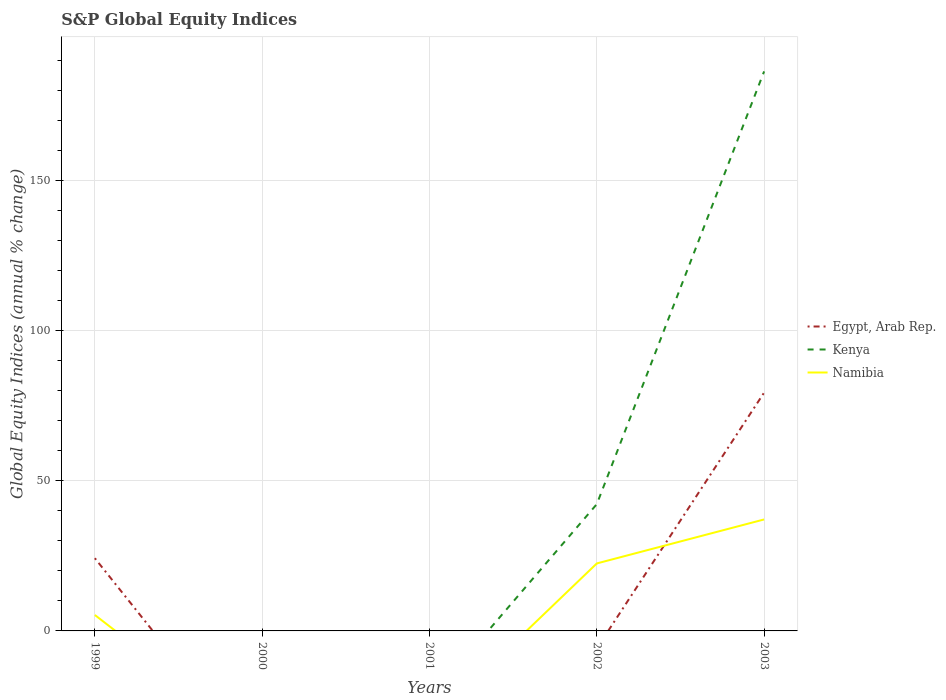Does the line corresponding to Egypt, Arab Rep. intersect with the line corresponding to Namibia?
Provide a short and direct response. Yes. Is the number of lines equal to the number of legend labels?
Your answer should be very brief. No. What is the total global equity indices in Namibia in the graph?
Your response must be concise. -14.64. What is the difference between the highest and the second highest global equity indices in Egypt, Arab Rep.?
Your answer should be very brief. 79.31. What is the difference between the highest and the lowest global equity indices in Namibia?
Offer a terse response. 2. Is the global equity indices in Egypt, Arab Rep. strictly greater than the global equity indices in Kenya over the years?
Your answer should be very brief. No. How many years are there in the graph?
Keep it short and to the point. 5. What is the difference between two consecutive major ticks on the Y-axis?
Ensure brevity in your answer.  50. Are the values on the major ticks of Y-axis written in scientific E-notation?
Your response must be concise. No. Where does the legend appear in the graph?
Make the answer very short. Center right. What is the title of the graph?
Provide a short and direct response. S&P Global Equity Indices. What is the label or title of the X-axis?
Provide a short and direct response. Years. What is the label or title of the Y-axis?
Offer a terse response. Global Equity Indices (annual % change). What is the Global Equity Indices (annual % change) in Egypt, Arab Rep. in 1999?
Keep it short and to the point. 24.2. What is the Global Equity Indices (annual % change) of Kenya in 1999?
Offer a very short reply. 0. What is the Global Equity Indices (annual % change) in Namibia in 1999?
Your answer should be very brief. 5.3. What is the Global Equity Indices (annual % change) in Namibia in 2000?
Make the answer very short. 0. What is the Global Equity Indices (annual % change) of Egypt, Arab Rep. in 2001?
Make the answer very short. 0. What is the Global Equity Indices (annual % change) of Namibia in 2001?
Offer a terse response. 0. What is the Global Equity Indices (annual % change) of Kenya in 2002?
Your response must be concise. 42.19. What is the Global Equity Indices (annual % change) in Namibia in 2002?
Ensure brevity in your answer.  22.46. What is the Global Equity Indices (annual % change) of Egypt, Arab Rep. in 2003?
Keep it short and to the point. 79.31. What is the Global Equity Indices (annual % change) of Kenya in 2003?
Keep it short and to the point. 186.21. What is the Global Equity Indices (annual % change) of Namibia in 2003?
Keep it short and to the point. 37.1. Across all years, what is the maximum Global Equity Indices (annual % change) in Egypt, Arab Rep.?
Ensure brevity in your answer.  79.31. Across all years, what is the maximum Global Equity Indices (annual % change) in Kenya?
Offer a very short reply. 186.21. Across all years, what is the maximum Global Equity Indices (annual % change) of Namibia?
Your answer should be very brief. 37.1. Across all years, what is the minimum Global Equity Indices (annual % change) of Egypt, Arab Rep.?
Offer a very short reply. 0. Across all years, what is the minimum Global Equity Indices (annual % change) in Kenya?
Keep it short and to the point. 0. What is the total Global Equity Indices (annual % change) of Egypt, Arab Rep. in the graph?
Offer a terse response. 103.51. What is the total Global Equity Indices (annual % change) of Kenya in the graph?
Make the answer very short. 228.4. What is the total Global Equity Indices (annual % change) in Namibia in the graph?
Offer a terse response. 64.86. What is the difference between the Global Equity Indices (annual % change) of Namibia in 1999 and that in 2002?
Offer a very short reply. -17.16. What is the difference between the Global Equity Indices (annual % change) in Egypt, Arab Rep. in 1999 and that in 2003?
Keep it short and to the point. -55.11. What is the difference between the Global Equity Indices (annual % change) in Namibia in 1999 and that in 2003?
Provide a succinct answer. -31.8. What is the difference between the Global Equity Indices (annual % change) of Kenya in 2002 and that in 2003?
Your answer should be compact. -144.02. What is the difference between the Global Equity Indices (annual % change) of Namibia in 2002 and that in 2003?
Offer a terse response. -14.64. What is the difference between the Global Equity Indices (annual % change) of Egypt, Arab Rep. in 1999 and the Global Equity Indices (annual % change) of Kenya in 2002?
Provide a succinct answer. -17.99. What is the difference between the Global Equity Indices (annual % change) in Egypt, Arab Rep. in 1999 and the Global Equity Indices (annual % change) in Namibia in 2002?
Offer a terse response. 1.74. What is the difference between the Global Equity Indices (annual % change) in Egypt, Arab Rep. in 1999 and the Global Equity Indices (annual % change) in Kenya in 2003?
Ensure brevity in your answer.  -162.01. What is the difference between the Global Equity Indices (annual % change) in Kenya in 2002 and the Global Equity Indices (annual % change) in Namibia in 2003?
Provide a succinct answer. 5.09. What is the average Global Equity Indices (annual % change) in Egypt, Arab Rep. per year?
Offer a very short reply. 20.7. What is the average Global Equity Indices (annual % change) of Kenya per year?
Make the answer very short. 45.68. What is the average Global Equity Indices (annual % change) of Namibia per year?
Provide a short and direct response. 12.97. In the year 1999, what is the difference between the Global Equity Indices (annual % change) in Egypt, Arab Rep. and Global Equity Indices (annual % change) in Namibia?
Keep it short and to the point. 18.9. In the year 2002, what is the difference between the Global Equity Indices (annual % change) in Kenya and Global Equity Indices (annual % change) in Namibia?
Your response must be concise. 19.73. In the year 2003, what is the difference between the Global Equity Indices (annual % change) of Egypt, Arab Rep. and Global Equity Indices (annual % change) of Kenya?
Offer a terse response. -106.9. In the year 2003, what is the difference between the Global Equity Indices (annual % change) in Egypt, Arab Rep. and Global Equity Indices (annual % change) in Namibia?
Make the answer very short. 42.21. In the year 2003, what is the difference between the Global Equity Indices (annual % change) in Kenya and Global Equity Indices (annual % change) in Namibia?
Offer a very short reply. 149.11. What is the ratio of the Global Equity Indices (annual % change) of Namibia in 1999 to that in 2002?
Ensure brevity in your answer.  0.24. What is the ratio of the Global Equity Indices (annual % change) of Egypt, Arab Rep. in 1999 to that in 2003?
Ensure brevity in your answer.  0.31. What is the ratio of the Global Equity Indices (annual % change) in Namibia in 1999 to that in 2003?
Ensure brevity in your answer.  0.14. What is the ratio of the Global Equity Indices (annual % change) in Kenya in 2002 to that in 2003?
Offer a very short reply. 0.23. What is the ratio of the Global Equity Indices (annual % change) of Namibia in 2002 to that in 2003?
Your answer should be compact. 0.61. What is the difference between the highest and the second highest Global Equity Indices (annual % change) in Namibia?
Offer a very short reply. 14.64. What is the difference between the highest and the lowest Global Equity Indices (annual % change) in Egypt, Arab Rep.?
Provide a short and direct response. 79.31. What is the difference between the highest and the lowest Global Equity Indices (annual % change) of Kenya?
Your answer should be compact. 186.21. What is the difference between the highest and the lowest Global Equity Indices (annual % change) in Namibia?
Make the answer very short. 37.1. 